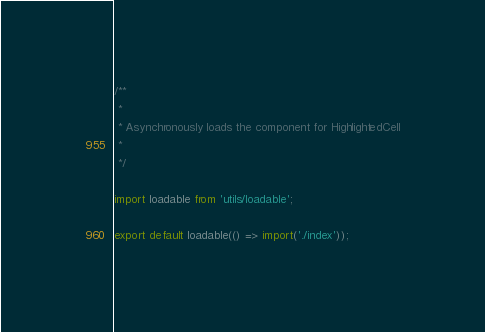<code> <loc_0><loc_0><loc_500><loc_500><_JavaScript_>/**
 *
 * Asynchronously loads the component for HighlightedCell
 *
 */

import loadable from 'utils/loadable';

export default loadable(() => import('./index'));
</code> 